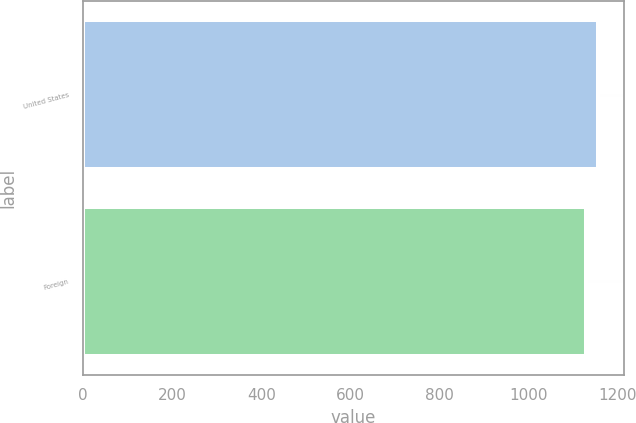<chart> <loc_0><loc_0><loc_500><loc_500><bar_chart><fcel>United States<fcel>Foreign<nl><fcel>1155<fcel>1129<nl></chart> 